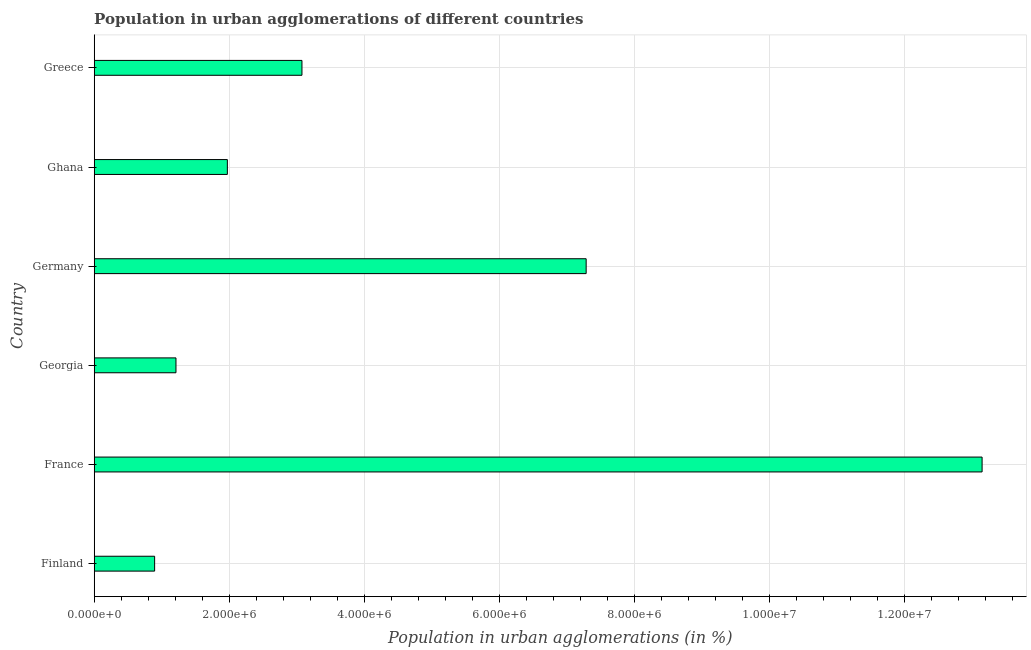What is the title of the graph?
Your answer should be compact. Population in urban agglomerations of different countries. What is the label or title of the X-axis?
Offer a very short reply. Population in urban agglomerations (in %). What is the population in urban agglomerations in Finland?
Provide a succinct answer. 8.95e+05. Across all countries, what is the maximum population in urban agglomerations?
Give a very brief answer. 1.31e+07. Across all countries, what is the minimum population in urban agglomerations?
Your response must be concise. 8.95e+05. In which country was the population in urban agglomerations maximum?
Your answer should be compact. France. In which country was the population in urban agglomerations minimum?
Make the answer very short. Finland. What is the sum of the population in urban agglomerations?
Give a very brief answer. 2.76e+07. What is the difference between the population in urban agglomerations in Ghana and Greece?
Your response must be concise. -1.10e+06. What is the average population in urban agglomerations per country?
Make the answer very short. 4.60e+06. What is the median population in urban agglomerations?
Offer a very short reply. 2.52e+06. What is the ratio of the population in urban agglomerations in France to that in Georgia?
Your response must be concise. 10.86. Is the population in urban agglomerations in Georgia less than that in Ghana?
Your response must be concise. Yes. Is the difference between the population in urban agglomerations in Georgia and Greece greater than the difference between any two countries?
Your answer should be very brief. No. What is the difference between the highest and the second highest population in urban agglomerations?
Keep it short and to the point. 5.86e+06. What is the difference between the highest and the lowest population in urban agglomerations?
Offer a terse response. 1.23e+07. How many bars are there?
Keep it short and to the point. 6. Are all the bars in the graph horizontal?
Your answer should be very brief. Yes. How many countries are there in the graph?
Your response must be concise. 6. What is the Population in urban agglomerations (in %) of Finland?
Keep it short and to the point. 8.95e+05. What is the Population in urban agglomerations (in %) of France?
Provide a short and direct response. 1.31e+07. What is the Population in urban agglomerations (in %) in Georgia?
Give a very brief answer. 1.21e+06. What is the Population in urban agglomerations (in %) of Germany?
Your answer should be compact. 7.28e+06. What is the Population in urban agglomerations (in %) of Ghana?
Give a very brief answer. 1.97e+06. What is the Population in urban agglomerations (in %) of Greece?
Your answer should be compact. 3.08e+06. What is the difference between the Population in urban agglomerations (in %) in Finland and France?
Offer a terse response. -1.23e+07. What is the difference between the Population in urban agglomerations (in %) in Finland and Georgia?
Your answer should be compact. -3.16e+05. What is the difference between the Population in urban agglomerations (in %) in Finland and Germany?
Provide a succinct answer. -6.39e+06. What is the difference between the Population in urban agglomerations (in %) in Finland and Ghana?
Give a very brief answer. -1.08e+06. What is the difference between the Population in urban agglomerations (in %) in Finland and Greece?
Provide a short and direct response. -2.18e+06. What is the difference between the Population in urban agglomerations (in %) in France and Georgia?
Your answer should be very brief. 1.19e+07. What is the difference between the Population in urban agglomerations (in %) in France and Germany?
Make the answer very short. 5.86e+06. What is the difference between the Population in urban agglomerations (in %) in France and Ghana?
Ensure brevity in your answer.  1.12e+07. What is the difference between the Population in urban agglomerations (in %) in France and Greece?
Your answer should be very brief. 1.01e+07. What is the difference between the Population in urban agglomerations (in %) in Georgia and Germany?
Offer a terse response. -6.07e+06. What is the difference between the Population in urban agglomerations (in %) in Georgia and Ghana?
Keep it short and to the point. -7.61e+05. What is the difference between the Population in urban agglomerations (in %) in Georgia and Greece?
Your answer should be very brief. -1.87e+06. What is the difference between the Population in urban agglomerations (in %) in Germany and Ghana?
Provide a succinct answer. 5.31e+06. What is the difference between the Population in urban agglomerations (in %) in Germany and Greece?
Your answer should be compact. 4.21e+06. What is the difference between the Population in urban agglomerations (in %) in Ghana and Greece?
Your response must be concise. -1.10e+06. What is the ratio of the Population in urban agglomerations (in %) in Finland to that in France?
Provide a succinct answer. 0.07. What is the ratio of the Population in urban agglomerations (in %) in Finland to that in Georgia?
Provide a succinct answer. 0.74. What is the ratio of the Population in urban agglomerations (in %) in Finland to that in Germany?
Your answer should be compact. 0.12. What is the ratio of the Population in urban agglomerations (in %) in Finland to that in Ghana?
Offer a very short reply. 0.45. What is the ratio of the Population in urban agglomerations (in %) in Finland to that in Greece?
Your answer should be very brief. 0.29. What is the ratio of the Population in urban agglomerations (in %) in France to that in Georgia?
Provide a succinct answer. 10.86. What is the ratio of the Population in urban agglomerations (in %) in France to that in Germany?
Your response must be concise. 1.8. What is the ratio of the Population in urban agglomerations (in %) in France to that in Ghana?
Provide a succinct answer. 6.67. What is the ratio of the Population in urban agglomerations (in %) in France to that in Greece?
Offer a terse response. 4.27. What is the ratio of the Population in urban agglomerations (in %) in Georgia to that in Germany?
Keep it short and to the point. 0.17. What is the ratio of the Population in urban agglomerations (in %) in Georgia to that in Ghana?
Provide a short and direct response. 0.61. What is the ratio of the Population in urban agglomerations (in %) in Georgia to that in Greece?
Make the answer very short. 0.39. What is the ratio of the Population in urban agglomerations (in %) in Germany to that in Ghana?
Your answer should be very brief. 3.69. What is the ratio of the Population in urban agglomerations (in %) in Germany to that in Greece?
Offer a very short reply. 2.37. What is the ratio of the Population in urban agglomerations (in %) in Ghana to that in Greece?
Provide a short and direct response. 0.64. 